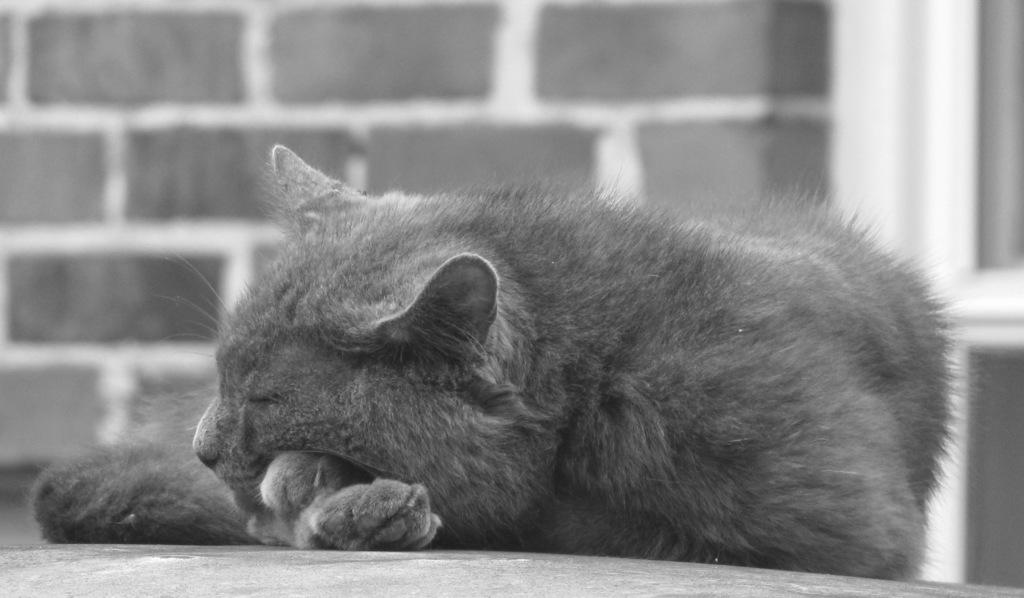What type of animal is in the image? There is a cat in the image. Where is the cat located in the image? The cat is in the center of the image. What surface is the cat on in the image? The cat is on the floor in the image. How does the cat contribute to the harmony of the women in the image? There are no women present in the image, and the cat's presence does not affect any harmony among them. 